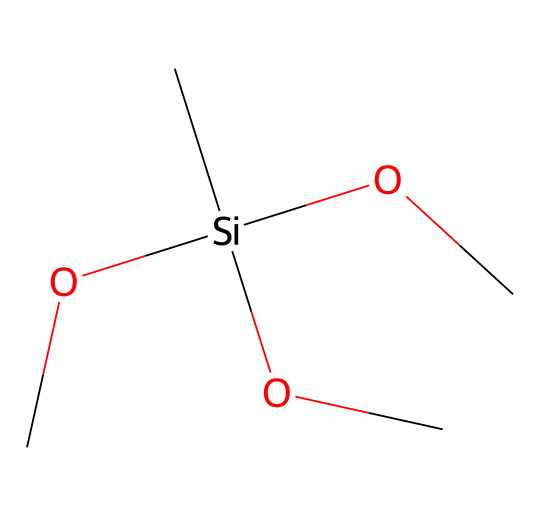What is the main functional group in this molecule? The molecule contains a silicon atom bonded to three methoxy groups (OC) and one carbon (C). The methoxy groups indicate that the functional group is related to silanes and provides properties such as reactivity with moisture.
Answer: silanol How many carbon atoms are present in this molecule? By examining the structure, there is one carbon atom that is directly connected to the silicon atom and three additional carbon atoms from the three methoxy groups, resulting in a total of four carbon atoms.
Answer: four What is the total number of oxygen atoms in the molecule? The molecule contains three methoxy groups, each contributing one oxygen atom, totaling three oxygen atoms. There are no additional oxygen atoms in the compound.
Answer: three Which atoms determine the reactivity of this silane? The silicon atom is the central atom that is highly reactive due to its ability to form bonds with various substrates, particularly in relation to the methoxy groups which can hydrolyze in moisture environments.
Answer: silicon What type of solvent can this silane be dissolved in? Given the presence of methoxy groups, which are polar, this silane is likely soluble in polar solvents such as alcohols and possibly water due to the potential for hydrolysis.
Answer: polar solvents 